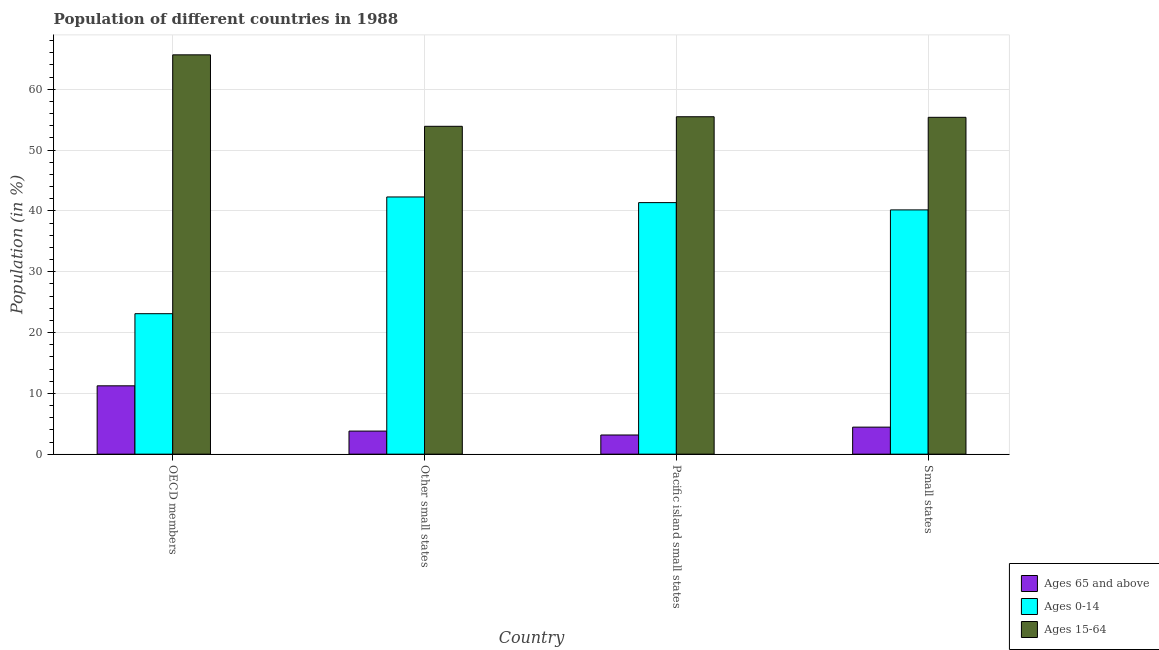How many groups of bars are there?
Your answer should be very brief. 4. Are the number of bars per tick equal to the number of legend labels?
Provide a succinct answer. Yes. Are the number of bars on each tick of the X-axis equal?
Your response must be concise. Yes. How many bars are there on the 3rd tick from the right?
Ensure brevity in your answer.  3. What is the label of the 3rd group of bars from the left?
Your response must be concise. Pacific island small states. In how many cases, is the number of bars for a given country not equal to the number of legend labels?
Provide a short and direct response. 0. What is the percentage of population within the age-group 15-64 in Other small states?
Ensure brevity in your answer.  53.91. Across all countries, what is the maximum percentage of population within the age-group 0-14?
Provide a short and direct response. 42.29. Across all countries, what is the minimum percentage of population within the age-group 15-64?
Make the answer very short. 53.91. In which country was the percentage of population within the age-group 0-14 minimum?
Offer a terse response. OECD members. What is the total percentage of population within the age-group 0-14 in the graph?
Your response must be concise. 146.92. What is the difference between the percentage of population within the age-group 15-64 in OECD members and that in Small states?
Keep it short and to the point. 10.27. What is the difference between the percentage of population within the age-group 0-14 in OECD members and the percentage of population within the age-group 15-64 in Other small states?
Ensure brevity in your answer.  -30.81. What is the average percentage of population within the age-group 15-64 per country?
Your answer should be compact. 57.61. What is the difference between the percentage of population within the age-group of 65 and above and percentage of population within the age-group 0-14 in Other small states?
Keep it short and to the point. -38.5. In how many countries, is the percentage of population within the age-group 0-14 greater than 32 %?
Your answer should be compact. 3. What is the ratio of the percentage of population within the age-group 15-64 in Pacific island small states to that in Small states?
Ensure brevity in your answer.  1. What is the difference between the highest and the second highest percentage of population within the age-group of 65 and above?
Offer a very short reply. 6.79. What is the difference between the highest and the lowest percentage of population within the age-group of 65 and above?
Provide a short and direct response. 8.08. What does the 3rd bar from the left in Other small states represents?
Offer a terse response. Ages 15-64. What does the 3rd bar from the right in Pacific island small states represents?
Ensure brevity in your answer.  Ages 65 and above. Is it the case that in every country, the sum of the percentage of population within the age-group of 65 and above and percentage of population within the age-group 0-14 is greater than the percentage of population within the age-group 15-64?
Keep it short and to the point. No. How many bars are there?
Keep it short and to the point. 12. What is the difference between two consecutive major ticks on the Y-axis?
Offer a very short reply. 10. Are the values on the major ticks of Y-axis written in scientific E-notation?
Ensure brevity in your answer.  No. Does the graph contain any zero values?
Provide a succinct answer. No. Does the graph contain grids?
Make the answer very short. Yes. Where does the legend appear in the graph?
Keep it short and to the point. Bottom right. How many legend labels are there?
Offer a terse response. 3. What is the title of the graph?
Make the answer very short. Population of different countries in 1988. Does "Solid fuel" appear as one of the legend labels in the graph?
Provide a succinct answer. No. What is the label or title of the X-axis?
Offer a very short reply. Country. What is the Population (in %) in Ages 65 and above in OECD members?
Offer a very short reply. 11.24. What is the Population (in %) in Ages 0-14 in OECD members?
Keep it short and to the point. 23.1. What is the Population (in %) of Ages 15-64 in OECD members?
Keep it short and to the point. 65.66. What is the Population (in %) in Ages 65 and above in Other small states?
Your response must be concise. 3.8. What is the Population (in %) of Ages 0-14 in Other small states?
Offer a terse response. 42.29. What is the Population (in %) of Ages 15-64 in Other small states?
Offer a terse response. 53.91. What is the Population (in %) in Ages 65 and above in Pacific island small states?
Your answer should be compact. 3.15. What is the Population (in %) in Ages 0-14 in Pacific island small states?
Offer a very short reply. 41.36. What is the Population (in %) of Ages 15-64 in Pacific island small states?
Ensure brevity in your answer.  55.48. What is the Population (in %) in Ages 65 and above in Small states?
Your answer should be compact. 4.44. What is the Population (in %) in Ages 0-14 in Small states?
Make the answer very short. 40.17. What is the Population (in %) in Ages 15-64 in Small states?
Ensure brevity in your answer.  55.39. Across all countries, what is the maximum Population (in %) of Ages 65 and above?
Your answer should be compact. 11.24. Across all countries, what is the maximum Population (in %) of Ages 0-14?
Provide a succinct answer. 42.29. Across all countries, what is the maximum Population (in %) of Ages 15-64?
Make the answer very short. 65.66. Across all countries, what is the minimum Population (in %) of Ages 65 and above?
Ensure brevity in your answer.  3.15. Across all countries, what is the minimum Population (in %) of Ages 0-14?
Your answer should be very brief. 23.1. Across all countries, what is the minimum Population (in %) of Ages 15-64?
Your answer should be very brief. 53.91. What is the total Population (in %) in Ages 65 and above in the graph?
Offer a very short reply. 22.63. What is the total Population (in %) of Ages 0-14 in the graph?
Offer a terse response. 146.92. What is the total Population (in %) in Ages 15-64 in the graph?
Provide a short and direct response. 230.45. What is the difference between the Population (in %) of Ages 65 and above in OECD members and that in Other small states?
Ensure brevity in your answer.  7.44. What is the difference between the Population (in %) of Ages 0-14 in OECD members and that in Other small states?
Provide a succinct answer. -19.19. What is the difference between the Population (in %) of Ages 15-64 in OECD members and that in Other small states?
Give a very brief answer. 11.75. What is the difference between the Population (in %) in Ages 65 and above in OECD members and that in Pacific island small states?
Your answer should be very brief. 8.08. What is the difference between the Population (in %) in Ages 0-14 in OECD members and that in Pacific island small states?
Ensure brevity in your answer.  -18.26. What is the difference between the Population (in %) of Ages 15-64 in OECD members and that in Pacific island small states?
Your response must be concise. 10.18. What is the difference between the Population (in %) in Ages 65 and above in OECD members and that in Small states?
Your answer should be very brief. 6.79. What is the difference between the Population (in %) of Ages 0-14 in OECD members and that in Small states?
Make the answer very short. -17.07. What is the difference between the Population (in %) of Ages 15-64 in OECD members and that in Small states?
Offer a terse response. 10.27. What is the difference between the Population (in %) of Ages 65 and above in Other small states and that in Pacific island small states?
Your answer should be compact. 0.64. What is the difference between the Population (in %) of Ages 0-14 in Other small states and that in Pacific island small states?
Your answer should be compact. 0.93. What is the difference between the Population (in %) in Ages 15-64 in Other small states and that in Pacific island small states?
Your response must be concise. -1.57. What is the difference between the Population (in %) in Ages 65 and above in Other small states and that in Small states?
Your answer should be very brief. -0.65. What is the difference between the Population (in %) of Ages 0-14 in Other small states and that in Small states?
Ensure brevity in your answer.  2.13. What is the difference between the Population (in %) of Ages 15-64 in Other small states and that in Small states?
Provide a short and direct response. -1.48. What is the difference between the Population (in %) in Ages 65 and above in Pacific island small states and that in Small states?
Ensure brevity in your answer.  -1.29. What is the difference between the Population (in %) in Ages 0-14 in Pacific island small states and that in Small states?
Provide a succinct answer. 1.2. What is the difference between the Population (in %) in Ages 15-64 in Pacific island small states and that in Small states?
Ensure brevity in your answer.  0.1. What is the difference between the Population (in %) in Ages 65 and above in OECD members and the Population (in %) in Ages 0-14 in Other small states?
Make the answer very short. -31.05. What is the difference between the Population (in %) in Ages 65 and above in OECD members and the Population (in %) in Ages 15-64 in Other small states?
Your response must be concise. -42.67. What is the difference between the Population (in %) of Ages 0-14 in OECD members and the Population (in %) of Ages 15-64 in Other small states?
Keep it short and to the point. -30.81. What is the difference between the Population (in %) in Ages 65 and above in OECD members and the Population (in %) in Ages 0-14 in Pacific island small states?
Offer a very short reply. -30.12. What is the difference between the Population (in %) of Ages 65 and above in OECD members and the Population (in %) of Ages 15-64 in Pacific island small states?
Keep it short and to the point. -44.25. What is the difference between the Population (in %) of Ages 0-14 in OECD members and the Population (in %) of Ages 15-64 in Pacific island small states?
Ensure brevity in your answer.  -32.38. What is the difference between the Population (in %) in Ages 65 and above in OECD members and the Population (in %) in Ages 0-14 in Small states?
Offer a terse response. -28.93. What is the difference between the Population (in %) of Ages 65 and above in OECD members and the Population (in %) of Ages 15-64 in Small states?
Keep it short and to the point. -44.15. What is the difference between the Population (in %) of Ages 0-14 in OECD members and the Population (in %) of Ages 15-64 in Small states?
Ensure brevity in your answer.  -32.29. What is the difference between the Population (in %) in Ages 65 and above in Other small states and the Population (in %) in Ages 0-14 in Pacific island small states?
Give a very brief answer. -37.57. What is the difference between the Population (in %) of Ages 65 and above in Other small states and the Population (in %) of Ages 15-64 in Pacific island small states?
Keep it short and to the point. -51.69. What is the difference between the Population (in %) of Ages 0-14 in Other small states and the Population (in %) of Ages 15-64 in Pacific island small states?
Your answer should be very brief. -13.19. What is the difference between the Population (in %) in Ages 65 and above in Other small states and the Population (in %) in Ages 0-14 in Small states?
Ensure brevity in your answer.  -36.37. What is the difference between the Population (in %) in Ages 65 and above in Other small states and the Population (in %) in Ages 15-64 in Small states?
Your answer should be very brief. -51.59. What is the difference between the Population (in %) in Ages 0-14 in Other small states and the Population (in %) in Ages 15-64 in Small states?
Your answer should be very brief. -13.1. What is the difference between the Population (in %) of Ages 65 and above in Pacific island small states and the Population (in %) of Ages 0-14 in Small states?
Make the answer very short. -37.01. What is the difference between the Population (in %) of Ages 65 and above in Pacific island small states and the Population (in %) of Ages 15-64 in Small states?
Keep it short and to the point. -52.24. What is the difference between the Population (in %) in Ages 0-14 in Pacific island small states and the Population (in %) in Ages 15-64 in Small states?
Offer a very short reply. -14.03. What is the average Population (in %) of Ages 65 and above per country?
Provide a succinct answer. 5.66. What is the average Population (in %) in Ages 0-14 per country?
Keep it short and to the point. 36.73. What is the average Population (in %) of Ages 15-64 per country?
Offer a very short reply. 57.61. What is the difference between the Population (in %) in Ages 65 and above and Population (in %) in Ages 0-14 in OECD members?
Make the answer very short. -11.86. What is the difference between the Population (in %) in Ages 65 and above and Population (in %) in Ages 15-64 in OECD members?
Your answer should be very brief. -54.42. What is the difference between the Population (in %) of Ages 0-14 and Population (in %) of Ages 15-64 in OECD members?
Keep it short and to the point. -42.56. What is the difference between the Population (in %) in Ages 65 and above and Population (in %) in Ages 0-14 in Other small states?
Offer a very short reply. -38.5. What is the difference between the Population (in %) in Ages 65 and above and Population (in %) in Ages 15-64 in Other small states?
Make the answer very short. -50.12. What is the difference between the Population (in %) in Ages 0-14 and Population (in %) in Ages 15-64 in Other small states?
Your response must be concise. -11.62. What is the difference between the Population (in %) in Ages 65 and above and Population (in %) in Ages 0-14 in Pacific island small states?
Give a very brief answer. -38.21. What is the difference between the Population (in %) in Ages 65 and above and Population (in %) in Ages 15-64 in Pacific island small states?
Your answer should be very brief. -52.33. What is the difference between the Population (in %) in Ages 0-14 and Population (in %) in Ages 15-64 in Pacific island small states?
Provide a short and direct response. -14.12. What is the difference between the Population (in %) in Ages 65 and above and Population (in %) in Ages 0-14 in Small states?
Give a very brief answer. -35.72. What is the difference between the Population (in %) in Ages 65 and above and Population (in %) in Ages 15-64 in Small states?
Offer a terse response. -50.94. What is the difference between the Population (in %) in Ages 0-14 and Population (in %) in Ages 15-64 in Small states?
Keep it short and to the point. -15.22. What is the ratio of the Population (in %) in Ages 65 and above in OECD members to that in Other small states?
Provide a short and direct response. 2.96. What is the ratio of the Population (in %) of Ages 0-14 in OECD members to that in Other small states?
Ensure brevity in your answer.  0.55. What is the ratio of the Population (in %) of Ages 15-64 in OECD members to that in Other small states?
Your answer should be compact. 1.22. What is the ratio of the Population (in %) in Ages 65 and above in OECD members to that in Pacific island small states?
Keep it short and to the point. 3.56. What is the ratio of the Population (in %) of Ages 0-14 in OECD members to that in Pacific island small states?
Your answer should be compact. 0.56. What is the ratio of the Population (in %) of Ages 15-64 in OECD members to that in Pacific island small states?
Keep it short and to the point. 1.18. What is the ratio of the Population (in %) of Ages 65 and above in OECD members to that in Small states?
Your answer should be compact. 2.53. What is the ratio of the Population (in %) in Ages 0-14 in OECD members to that in Small states?
Provide a succinct answer. 0.58. What is the ratio of the Population (in %) of Ages 15-64 in OECD members to that in Small states?
Provide a short and direct response. 1.19. What is the ratio of the Population (in %) of Ages 65 and above in Other small states to that in Pacific island small states?
Provide a short and direct response. 1.2. What is the ratio of the Population (in %) of Ages 0-14 in Other small states to that in Pacific island small states?
Provide a short and direct response. 1.02. What is the ratio of the Population (in %) of Ages 15-64 in Other small states to that in Pacific island small states?
Offer a very short reply. 0.97. What is the ratio of the Population (in %) in Ages 65 and above in Other small states to that in Small states?
Provide a succinct answer. 0.85. What is the ratio of the Population (in %) in Ages 0-14 in Other small states to that in Small states?
Keep it short and to the point. 1.05. What is the ratio of the Population (in %) in Ages 15-64 in Other small states to that in Small states?
Offer a very short reply. 0.97. What is the ratio of the Population (in %) in Ages 65 and above in Pacific island small states to that in Small states?
Give a very brief answer. 0.71. What is the ratio of the Population (in %) in Ages 0-14 in Pacific island small states to that in Small states?
Your answer should be compact. 1.03. What is the ratio of the Population (in %) in Ages 15-64 in Pacific island small states to that in Small states?
Your response must be concise. 1. What is the difference between the highest and the second highest Population (in %) in Ages 65 and above?
Keep it short and to the point. 6.79. What is the difference between the highest and the second highest Population (in %) in Ages 0-14?
Your answer should be very brief. 0.93. What is the difference between the highest and the second highest Population (in %) of Ages 15-64?
Ensure brevity in your answer.  10.18. What is the difference between the highest and the lowest Population (in %) of Ages 65 and above?
Provide a short and direct response. 8.08. What is the difference between the highest and the lowest Population (in %) in Ages 0-14?
Make the answer very short. 19.19. What is the difference between the highest and the lowest Population (in %) in Ages 15-64?
Your response must be concise. 11.75. 